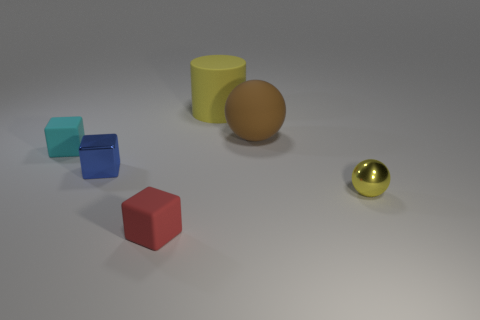Add 1 small blue things. How many objects exist? 7 Subtract all spheres. How many objects are left? 4 Add 2 rubber blocks. How many rubber blocks exist? 4 Subtract 0 gray balls. How many objects are left? 6 Subtract all blue blocks. Subtract all metallic blocks. How many objects are left? 4 Add 4 brown matte spheres. How many brown matte spheres are left? 5 